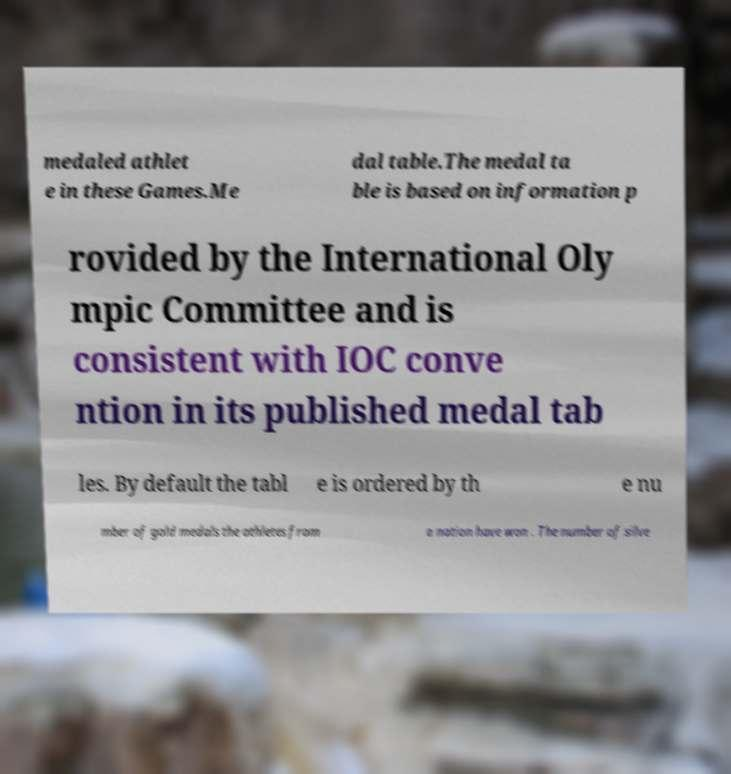Please read and relay the text visible in this image. What does it say? medaled athlet e in these Games.Me dal table.The medal ta ble is based on information p rovided by the International Oly mpic Committee and is consistent with IOC conve ntion in its published medal tab les. By default the tabl e is ordered by th e nu mber of gold medals the athletes from a nation have won . The number of silve 